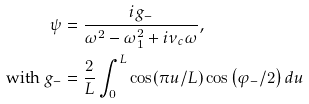<formula> <loc_0><loc_0><loc_500><loc_500>\psi & = \frac { i g _ { - } } { \omega ^ { 2 } - \omega _ { 1 } ^ { 2 } + i \nu _ { c } \omega } , \\ \text {with } g _ { - } & = \frac { 2 } { L } \int _ { 0 } ^ { L } \cos ( \pi u / L ) \cos \left ( \varphi _ { - } / 2 \right ) d u</formula> 